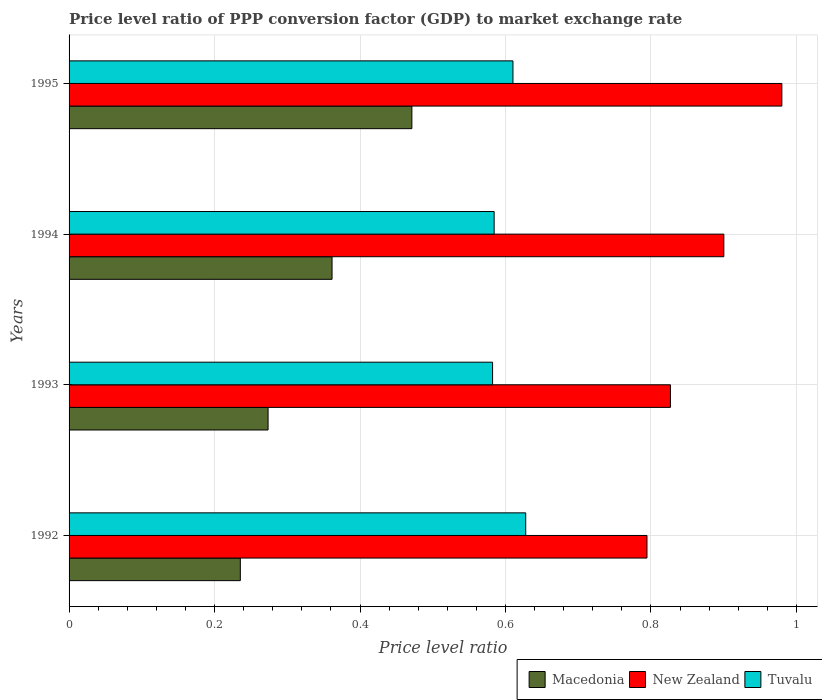How many groups of bars are there?
Give a very brief answer. 4. Are the number of bars on each tick of the Y-axis equal?
Make the answer very short. Yes. How many bars are there on the 4th tick from the bottom?
Offer a terse response. 3. What is the label of the 3rd group of bars from the top?
Keep it short and to the point. 1993. What is the price level ratio in Macedonia in 1994?
Ensure brevity in your answer.  0.36. Across all years, what is the maximum price level ratio in New Zealand?
Make the answer very short. 0.98. Across all years, what is the minimum price level ratio in Macedonia?
Offer a terse response. 0.24. In which year was the price level ratio in Macedonia maximum?
Your answer should be compact. 1995. In which year was the price level ratio in Macedonia minimum?
Your response must be concise. 1992. What is the total price level ratio in Tuvalu in the graph?
Your response must be concise. 2.4. What is the difference between the price level ratio in Macedonia in 1992 and that in 1995?
Your answer should be compact. -0.24. What is the difference between the price level ratio in New Zealand in 1993 and the price level ratio in Tuvalu in 1995?
Your answer should be compact. 0.22. What is the average price level ratio in New Zealand per year?
Your answer should be compact. 0.88. In the year 1994, what is the difference between the price level ratio in Macedonia and price level ratio in New Zealand?
Provide a succinct answer. -0.54. In how many years, is the price level ratio in Tuvalu greater than 0.8 ?
Provide a succinct answer. 0. What is the ratio of the price level ratio in Tuvalu in 1992 to that in 1995?
Offer a very short reply. 1.03. Is the price level ratio in Macedonia in 1992 less than that in 1993?
Make the answer very short. Yes. What is the difference between the highest and the second highest price level ratio in Tuvalu?
Give a very brief answer. 0.02. What is the difference between the highest and the lowest price level ratio in Macedonia?
Provide a succinct answer. 0.24. In how many years, is the price level ratio in Macedonia greater than the average price level ratio in Macedonia taken over all years?
Your answer should be very brief. 2. Is the sum of the price level ratio in New Zealand in 1993 and 1994 greater than the maximum price level ratio in Tuvalu across all years?
Your answer should be compact. Yes. What does the 3rd bar from the top in 1994 represents?
Your answer should be compact. Macedonia. What does the 3rd bar from the bottom in 1995 represents?
Ensure brevity in your answer.  Tuvalu. Is it the case that in every year, the sum of the price level ratio in Tuvalu and price level ratio in New Zealand is greater than the price level ratio in Macedonia?
Offer a very short reply. Yes. How many bars are there?
Keep it short and to the point. 12. Are all the bars in the graph horizontal?
Give a very brief answer. Yes. What is the difference between two consecutive major ticks on the X-axis?
Your response must be concise. 0.2. Does the graph contain any zero values?
Your answer should be very brief. No. Does the graph contain grids?
Ensure brevity in your answer.  Yes. Where does the legend appear in the graph?
Provide a succinct answer. Bottom right. What is the title of the graph?
Make the answer very short. Price level ratio of PPP conversion factor (GDP) to market exchange rate. Does "Euro area" appear as one of the legend labels in the graph?
Ensure brevity in your answer.  No. What is the label or title of the X-axis?
Your answer should be compact. Price level ratio. What is the Price level ratio in Macedonia in 1992?
Provide a short and direct response. 0.24. What is the Price level ratio in New Zealand in 1992?
Give a very brief answer. 0.79. What is the Price level ratio in Tuvalu in 1992?
Offer a terse response. 0.63. What is the Price level ratio in Macedonia in 1993?
Keep it short and to the point. 0.27. What is the Price level ratio of New Zealand in 1993?
Your answer should be compact. 0.83. What is the Price level ratio in Tuvalu in 1993?
Provide a short and direct response. 0.58. What is the Price level ratio of Macedonia in 1994?
Keep it short and to the point. 0.36. What is the Price level ratio of New Zealand in 1994?
Make the answer very short. 0.9. What is the Price level ratio of Tuvalu in 1994?
Give a very brief answer. 0.58. What is the Price level ratio of Macedonia in 1995?
Give a very brief answer. 0.47. What is the Price level ratio of New Zealand in 1995?
Your answer should be compact. 0.98. What is the Price level ratio of Tuvalu in 1995?
Your answer should be very brief. 0.61. Across all years, what is the maximum Price level ratio of Macedonia?
Make the answer very short. 0.47. Across all years, what is the maximum Price level ratio in New Zealand?
Your response must be concise. 0.98. Across all years, what is the maximum Price level ratio in Tuvalu?
Offer a very short reply. 0.63. Across all years, what is the minimum Price level ratio in Macedonia?
Offer a terse response. 0.24. Across all years, what is the minimum Price level ratio in New Zealand?
Provide a short and direct response. 0.79. Across all years, what is the minimum Price level ratio of Tuvalu?
Your answer should be compact. 0.58. What is the total Price level ratio of Macedonia in the graph?
Your answer should be compact. 1.34. What is the total Price level ratio of New Zealand in the graph?
Offer a terse response. 3.5. What is the total Price level ratio of Tuvalu in the graph?
Your answer should be compact. 2.4. What is the difference between the Price level ratio of Macedonia in 1992 and that in 1993?
Your answer should be very brief. -0.04. What is the difference between the Price level ratio of New Zealand in 1992 and that in 1993?
Offer a very short reply. -0.03. What is the difference between the Price level ratio in Tuvalu in 1992 and that in 1993?
Provide a succinct answer. 0.05. What is the difference between the Price level ratio in Macedonia in 1992 and that in 1994?
Your answer should be compact. -0.13. What is the difference between the Price level ratio in New Zealand in 1992 and that in 1994?
Your response must be concise. -0.11. What is the difference between the Price level ratio in Tuvalu in 1992 and that in 1994?
Your answer should be compact. 0.04. What is the difference between the Price level ratio in Macedonia in 1992 and that in 1995?
Your answer should be very brief. -0.24. What is the difference between the Price level ratio of New Zealand in 1992 and that in 1995?
Your answer should be compact. -0.19. What is the difference between the Price level ratio of Tuvalu in 1992 and that in 1995?
Your response must be concise. 0.02. What is the difference between the Price level ratio in Macedonia in 1993 and that in 1994?
Offer a very short reply. -0.09. What is the difference between the Price level ratio in New Zealand in 1993 and that in 1994?
Provide a succinct answer. -0.07. What is the difference between the Price level ratio of Tuvalu in 1993 and that in 1994?
Offer a terse response. -0. What is the difference between the Price level ratio in Macedonia in 1993 and that in 1995?
Your answer should be very brief. -0.2. What is the difference between the Price level ratio of New Zealand in 1993 and that in 1995?
Your answer should be very brief. -0.15. What is the difference between the Price level ratio in Tuvalu in 1993 and that in 1995?
Offer a terse response. -0.03. What is the difference between the Price level ratio of Macedonia in 1994 and that in 1995?
Keep it short and to the point. -0.11. What is the difference between the Price level ratio in New Zealand in 1994 and that in 1995?
Give a very brief answer. -0.08. What is the difference between the Price level ratio in Tuvalu in 1994 and that in 1995?
Provide a short and direct response. -0.03. What is the difference between the Price level ratio in Macedonia in 1992 and the Price level ratio in New Zealand in 1993?
Offer a very short reply. -0.59. What is the difference between the Price level ratio of Macedonia in 1992 and the Price level ratio of Tuvalu in 1993?
Offer a very short reply. -0.35. What is the difference between the Price level ratio in New Zealand in 1992 and the Price level ratio in Tuvalu in 1993?
Give a very brief answer. 0.21. What is the difference between the Price level ratio of Macedonia in 1992 and the Price level ratio of New Zealand in 1994?
Ensure brevity in your answer.  -0.66. What is the difference between the Price level ratio of Macedonia in 1992 and the Price level ratio of Tuvalu in 1994?
Give a very brief answer. -0.35. What is the difference between the Price level ratio in New Zealand in 1992 and the Price level ratio in Tuvalu in 1994?
Offer a terse response. 0.21. What is the difference between the Price level ratio of Macedonia in 1992 and the Price level ratio of New Zealand in 1995?
Make the answer very short. -0.74. What is the difference between the Price level ratio in Macedonia in 1992 and the Price level ratio in Tuvalu in 1995?
Provide a succinct answer. -0.37. What is the difference between the Price level ratio in New Zealand in 1992 and the Price level ratio in Tuvalu in 1995?
Make the answer very short. 0.18. What is the difference between the Price level ratio in Macedonia in 1993 and the Price level ratio in New Zealand in 1994?
Offer a very short reply. -0.63. What is the difference between the Price level ratio of Macedonia in 1993 and the Price level ratio of Tuvalu in 1994?
Provide a succinct answer. -0.31. What is the difference between the Price level ratio of New Zealand in 1993 and the Price level ratio of Tuvalu in 1994?
Make the answer very short. 0.24. What is the difference between the Price level ratio of Macedonia in 1993 and the Price level ratio of New Zealand in 1995?
Ensure brevity in your answer.  -0.71. What is the difference between the Price level ratio in Macedonia in 1993 and the Price level ratio in Tuvalu in 1995?
Keep it short and to the point. -0.34. What is the difference between the Price level ratio of New Zealand in 1993 and the Price level ratio of Tuvalu in 1995?
Make the answer very short. 0.22. What is the difference between the Price level ratio in Macedonia in 1994 and the Price level ratio in New Zealand in 1995?
Your answer should be very brief. -0.62. What is the difference between the Price level ratio in Macedonia in 1994 and the Price level ratio in Tuvalu in 1995?
Offer a very short reply. -0.25. What is the difference between the Price level ratio of New Zealand in 1994 and the Price level ratio of Tuvalu in 1995?
Provide a succinct answer. 0.29. What is the average Price level ratio of Macedonia per year?
Your answer should be very brief. 0.34. What is the average Price level ratio of New Zealand per year?
Your response must be concise. 0.88. What is the average Price level ratio in Tuvalu per year?
Your answer should be very brief. 0.6. In the year 1992, what is the difference between the Price level ratio in Macedonia and Price level ratio in New Zealand?
Provide a short and direct response. -0.56. In the year 1992, what is the difference between the Price level ratio in Macedonia and Price level ratio in Tuvalu?
Keep it short and to the point. -0.39. In the year 1993, what is the difference between the Price level ratio of Macedonia and Price level ratio of New Zealand?
Keep it short and to the point. -0.55. In the year 1993, what is the difference between the Price level ratio of Macedonia and Price level ratio of Tuvalu?
Your answer should be very brief. -0.31. In the year 1993, what is the difference between the Price level ratio in New Zealand and Price level ratio in Tuvalu?
Give a very brief answer. 0.24. In the year 1994, what is the difference between the Price level ratio in Macedonia and Price level ratio in New Zealand?
Keep it short and to the point. -0.54. In the year 1994, what is the difference between the Price level ratio in Macedonia and Price level ratio in Tuvalu?
Your answer should be compact. -0.22. In the year 1994, what is the difference between the Price level ratio in New Zealand and Price level ratio in Tuvalu?
Keep it short and to the point. 0.32. In the year 1995, what is the difference between the Price level ratio of Macedonia and Price level ratio of New Zealand?
Keep it short and to the point. -0.51. In the year 1995, what is the difference between the Price level ratio in Macedonia and Price level ratio in Tuvalu?
Provide a short and direct response. -0.14. In the year 1995, what is the difference between the Price level ratio in New Zealand and Price level ratio in Tuvalu?
Make the answer very short. 0.37. What is the ratio of the Price level ratio in Macedonia in 1992 to that in 1993?
Keep it short and to the point. 0.86. What is the ratio of the Price level ratio in Tuvalu in 1992 to that in 1993?
Your response must be concise. 1.08. What is the ratio of the Price level ratio in Macedonia in 1992 to that in 1994?
Provide a short and direct response. 0.65. What is the ratio of the Price level ratio in New Zealand in 1992 to that in 1994?
Make the answer very short. 0.88. What is the ratio of the Price level ratio of Tuvalu in 1992 to that in 1994?
Your answer should be very brief. 1.07. What is the ratio of the Price level ratio in Macedonia in 1992 to that in 1995?
Your answer should be very brief. 0.5. What is the ratio of the Price level ratio in New Zealand in 1992 to that in 1995?
Ensure brevity in your answer.  0.81. What is the ratio of the Price level ratio in Tuvalu in 1992 to that in 1995?
Offer a terse response. 1.03. What is the ratio of the Price level ratio in Macedonia in 1993 to that in 1994?
Give a very brief answer. 0.76. What is the ratio of the Price level ratio of New Zealand in 1993 to that in 1994?
Provide a succinct answer. 0.92. What is the ratio of the Price level ratio of Macedonia in 1993 to that in 1995?
Make the answer very short. 0.58. What is the ratio of the Price level ratio in New Zealand in 1993 to that in 1995?
Give a very brief answer. 0.84. What is the ratio of the Price level ratio of Tuvalu in 1993 to that in 1995?
Offer a terse response. 0.95. What is the ratio of the Price level ratio of Macedonia in 1994 to that in 1995?
Give a very brief answer. 0.77. What is the ratio of the Price level ratio of New Zealand in 1994 to that in 1995?
Ensure brevity in your answer.  0.92. What is the ratio of the Price level ratio of Tuvalu in 1994 to that in 1995?
Provide a succinct answer. 0.96. What is the difference between the highest and the second highest Price level ratio in Macedonia?
Make the answer very short. 0.11. What is the difference between the highest and the second highest Price level ratio in New Zealand?
Ensure brevity in your answer.  0.08. What is the difference between the highest and the second highest Price level ratio in Tuvalu?
Offer a very short reply. 0.02. What is the difference between the highest and the lowest Price level ratio in Macedonia?
Offer a terse response. 0.24. What is the difference between the highest and the lowest Price level ratio of New Zealand?
Make the answer very short. 0.19. What is the difference between the highest and the lowest Price level ratio in Tuvalu?
Give a very brief answer. 0.05. 